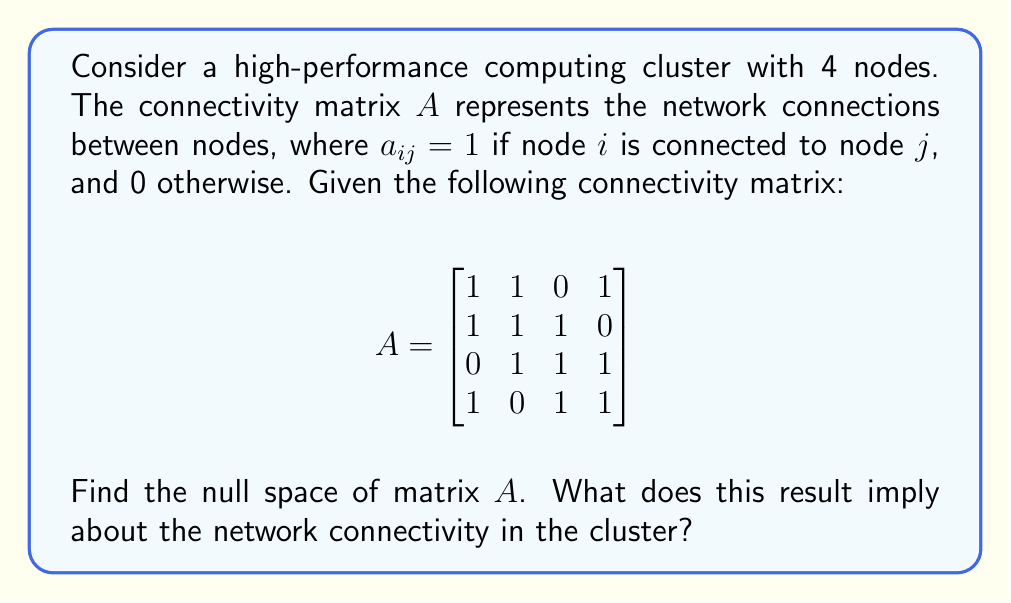Show me your answer to this math problem. To find the null space of matrix $A$, we need to solve the equation $A\mathbf{x} = \mathbf{0}$, where $\mathbf{x}$ is a vector in the null space.

Step 1: Set up the equation $A\mathbf{x} = \mathbf{0}$
$$\begin{bmatrix}
1 & 1 & 0 & 1 \\
1 & 1 & 1 & 0 \\
0 & 1 & 1 & 1 \\
1 & 0 & 1 & 1
\end{bmatrix} \begin{bmatrix} x_1 \\ x_2 \\ x_3 \\ x_4 \end{bmatrix} = \begin{bmatrix} 0 \\ 0 \\ 0 \\ 0 \end{bmatrix}$$

Step 2: Write out the system of equations
1) $x_1 + x_2 + x_4 = 0$
2) $x_1 + x_2 + x_3 = 0$
3) $x_2 + x_3 + x_4 = 0$
4) $x_1 + x_3 + x_4 = 0$

Step 3: Perform row reduction to find the rank of the matrix
$$\begin{bmatrix}
1 & 1 & 0 & 1 \\
0 & 0 & 1 & -1 \\
0 & 0 & 0 & 0 \\
0 & 0 & 0 & 0
\end{bmatrix}$$

The rank of matrix $A$ is 2.

Step 4: Calculate the dimension of the null space
dim(Null($A$)) = $n$ - rank($A$) = 4 - 2 = 2

Step 5: Find a basis for the null space
From the reduced matrix, we can express $x_1$ and $x_3$ in terms of $x_2$ and $x_4$:
$x_1 = -x_2 - x_4$
$x_3 = x_4$

Let $x_2 = t$ and $x_4 = s$. Then the general solution is:
$$\mathbf{x} = \begin{bmatrix} -t-s \\ t \\ s \\ s \end{bmatrix} = t\begin{bmatrix} -1 \\ 1 \\ 0 \\ 0 \end{bmatrix} + s\begin{bmatrix} -1 \\ 0 \\ 1 \\ 1 \end{bmatrix}$$

The null space is spanned by these two vectors:
$$\text{Null}(A) = \text{span}\left\{\begin{bmatrix} -1 \\ 1 \\ 0 \\ 0 \end{bmatrix}, \begin{bmatrix} -1 \\ 0 \\ 1 \\ 1 \end{bmatrix}\right\}$$

Interpretation: The non-zero null space implies that there are linear dependencies in the network connectivity. Specifically, the two basis vectors of the null space represent combinations of node states that, when applied, result in no net change in the network's connectivity state. This suggests redundancies or symmetries in the network topology, which could be leveraged for fault tolerance or load balancing in the high-performance computing cluster.
Answer: Null($A$) = span{$[-1, 1, 0, 0]^T$, $[-1, 0, 1, 1]^T$} 